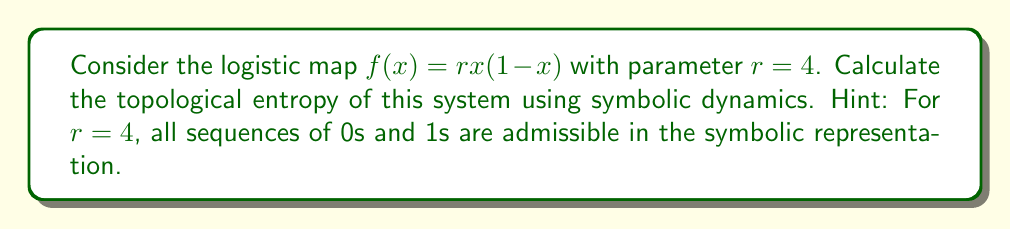What is the answer to this math problem? Let's approach this step-by-step:

1) For the logistic map with $r = 4$, we can divide the interval $[0,1]$ into two subintervals:
   $I_0 = [0, 0.5]$ and $I_1 = (0.5, 1]$

2) We assign symbol 0 to $I_0$ and symbol 1 to $I_1$. This creates a symbolic representation of the orbit.

3) For $r = 4$, it's known that all sequences of 0s and 1s are admissible. This means the system exhibits full shift dynamics.

4) The topological entropy $h$ for a full shift on $n$ symbols is given by:

   $h = \log_2(n)$

5) In our case, we have 2 symbols (0 and 1), so:

   $h = \log_2(2) = 1$

This result indicates that the system has the maximum possible entropy for a binary symbolic dynamics, reflecting its chaotic nature.
Answer: 1 